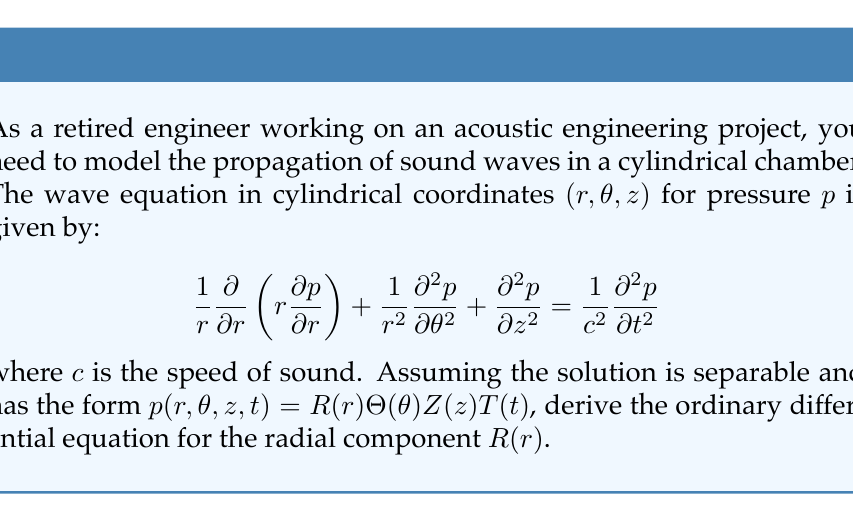Could you help me with this problem? Let's approach this step-by-step:

1) We start with the wave equation in cylindrical coordinates:

   $$\frac{1}{r}\frac{\partial}{\partial r}\left(r\frac{\partial p}{\partial r}\right) + \frac{1}{r^2}\frac{\partial^2 p}{\partial \theta^2} + \frac{\partial^2 p}{\partial z^2} = \frac{1}{c^2}\frac{\partial^2 p}{\partial t^2}$$

2) We assume a separable solution of the form:

   $$p(r,\theta,z,t) = R(r)\Theta(\theta)Z(z)T(t)$$

3) Substituting this into the wave equation:

   $$\frac{1}{r}\frac{d}{dr}\left(r\frac{dR}{dr}\right)\Theta Z T + \frac{1}{r^2}R\frac{d^2\Theta}{d\theta^2}ZT + RΘ\frac{d^2Z}{dz^2}T = \frac{1}{c^2}R\Theta Z\frac{d^2T}{dt^2}$$

4) Dividing both sides by $R\Theta Z T$:

   $$\frac{1}{rR}\frac{d}{dr}\left(r\frac{dR}{dr}\right) + \frac{1}{r^2\Theta}\frac{d^2\Theta}{d\theta^2} + \frac{1}{Z}\frac{d^2Z}{dz^2} = \frac{1}{c^2T}\frac{d^2T}{dt^2}$$

5) For this equation to be true for all $r$, $\theta$, $z$, and $t$, each term must be equal to a constant. Let's call these constants $-k_r^2$, $-m^2$, $-k_z^2$, and $\omega^2$ respectively:

   $$\frac{1}{rR}\frac{d}{dr}\left(r\frac{dR}{dr}\right) = -k_r^2$$
   $$\frac{1}{r^2\Theta}\frac{d^2\Theta}{d\theta^2} = -m^2$$
   $$\frac{1}{Z}\frac{d^2Z}{dz^2} = -k_z^2$$
   $$\frac{1}{c^2T}\frac{d^2T}{dt^2} = \omega^2$$

6) The equation for $R(r)$ can be rewritten as:

   $$\frac{d}{dr}\left(r\frac{dR}{dr}\right) + k_r^2rR = 0$$

7) This is the final form of the ordinary differential equation for the radial component $R(r)$.
Answer: The ordinary differential equation for the radial component $R(r)$ is:

$$\frac{d}{dr}\left(r\frac{dR}{dr}\right) + k_r^2rR = 0$$

This is known as Bessel's equation of order zero. 